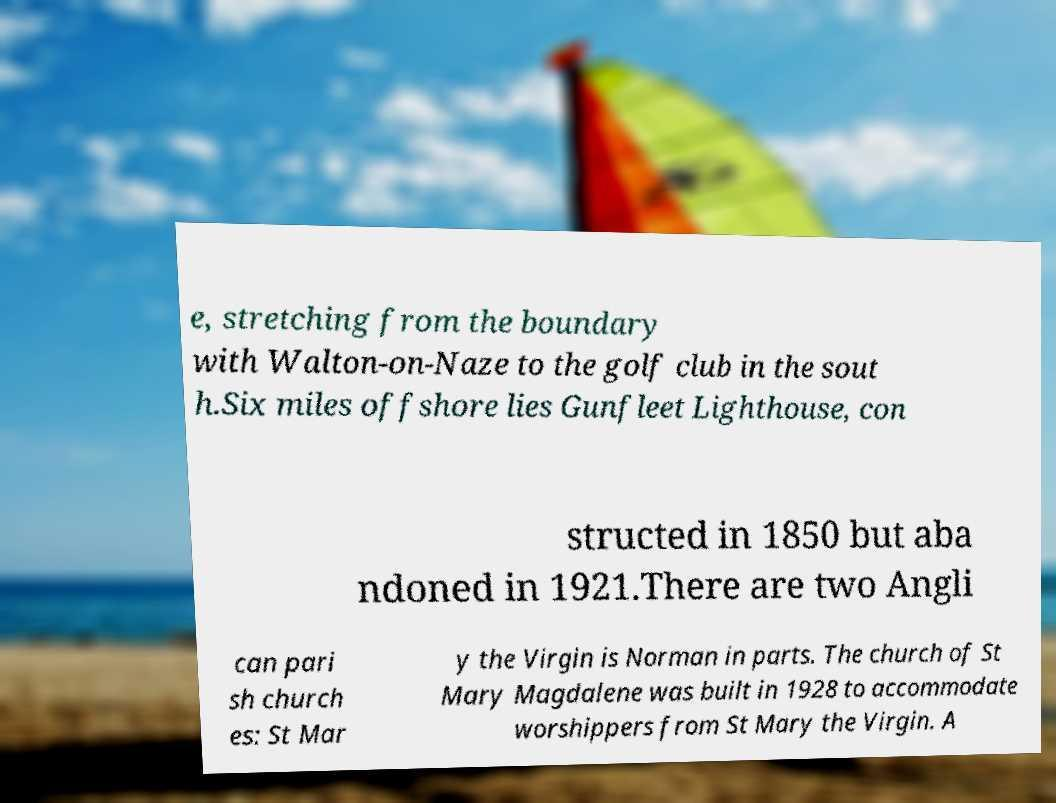For documentation purposes, I need the text within this image transcribed. Could you provide that? e, stretching from the boundary with Walton-on-Naze to the golf club in the sout h.Six miles offshore lies Gunfleet Lighthouse, con structed in 1850 but aba ndoned in 1921.There are two Angli can pari sh church es: St Mar y the Virgin is Norman in parts. The church of St Mary Magdalene was built in 1928 to accommodate worshippers from St Mary the Virgin. A 